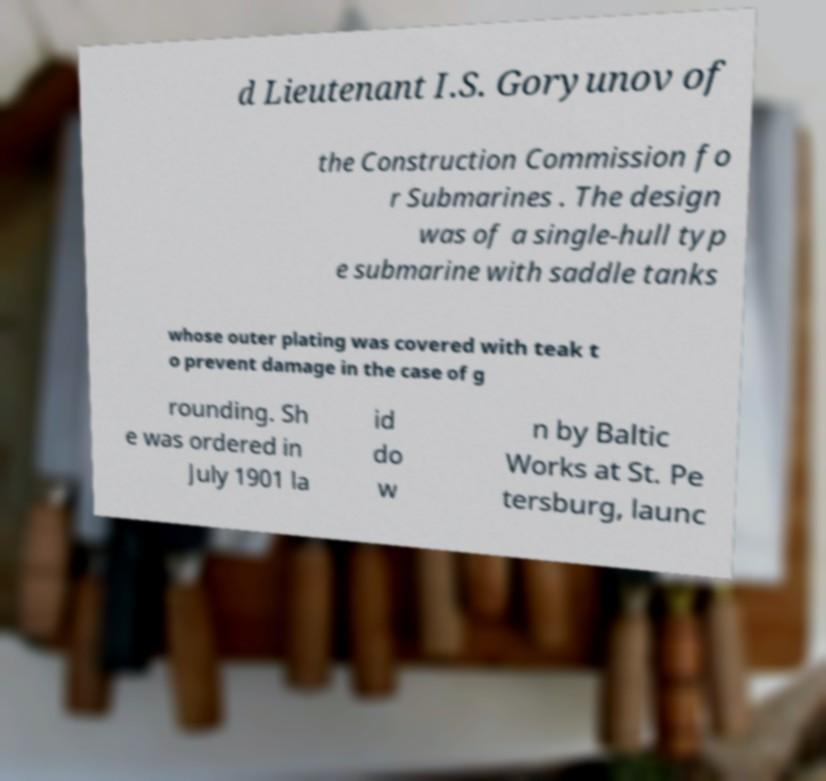Can you accurately transcribe the text from the provided image for me? d Lieutenant I.S. Goryunov of the Construction Commission fo r Submarines . The design was of a single-hull typ e submarine with saddle tanks whose outer plating was covered with teak t o prevent damage in the case of g rounding. Sh e was ordered in July 1901 la id do w n by Baltic Works at St. Pe tersburg, launc 